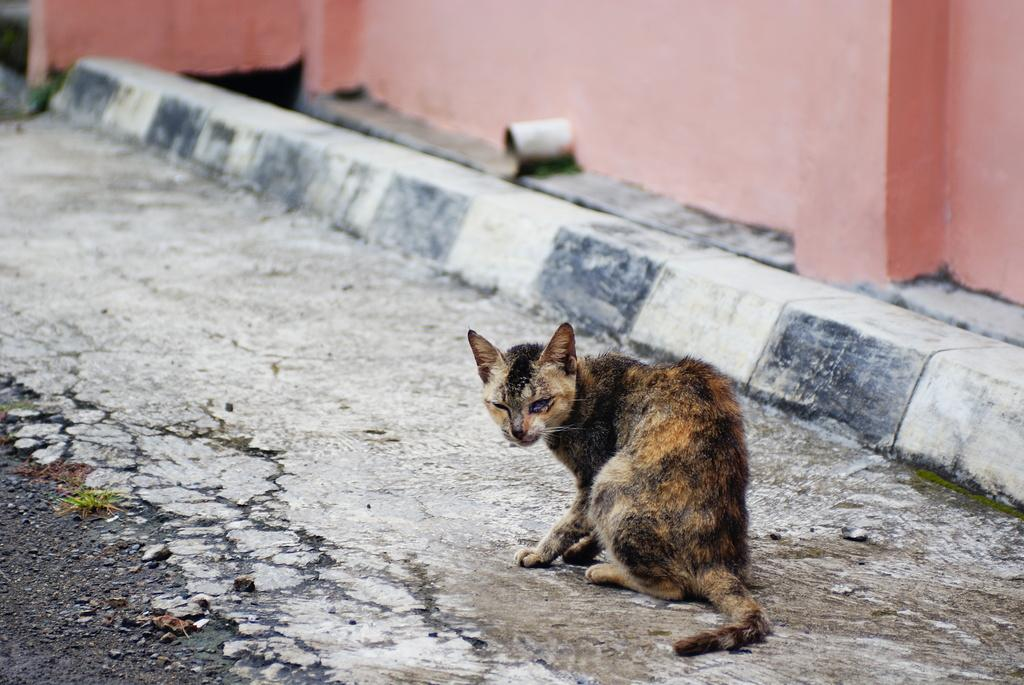What animal is present on the road in the image? There is a cat on the road in the image. What can be seen in the background of the image? There is a wall in the background of the image. What type of wrench is the cat using to fix the beds in the image? There is no wrench or beds present in the image; it only features a cat on the road and a wall in the background. 